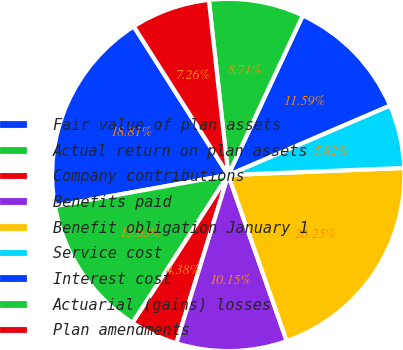<chart> <loc_0><loc_0><loc_500><loc_500><pie_chart><fcel>Fair value of plan assets<fcel>Actual return on plan assets<fcel>Company contributions<fcel>Benefits paid<fcel>Benefit obligation January 1<fcel>Service cost<fcel>Interest cost<fcel>Actuarial (gains) losses<fcel>Plan amendments<nl><fcel>18.81%<fcel>13.03%<fcel>4.38%<fcel>10.15%<fcel>20.25%<fcel>5.82%<fcel>11.59%<fcel>8.71%<fcel>7.26%<nl></chart> 